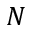Convert formula to latex. <formula><loc_0><loc_0><loc_500><loc_500>N</formula> 